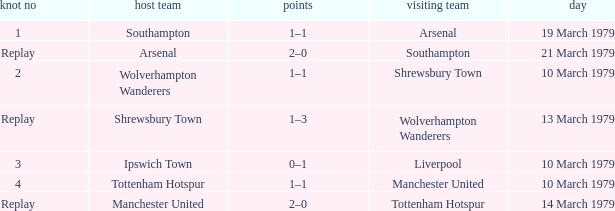Which tie number had an away team of Arsenal? 1.0. 